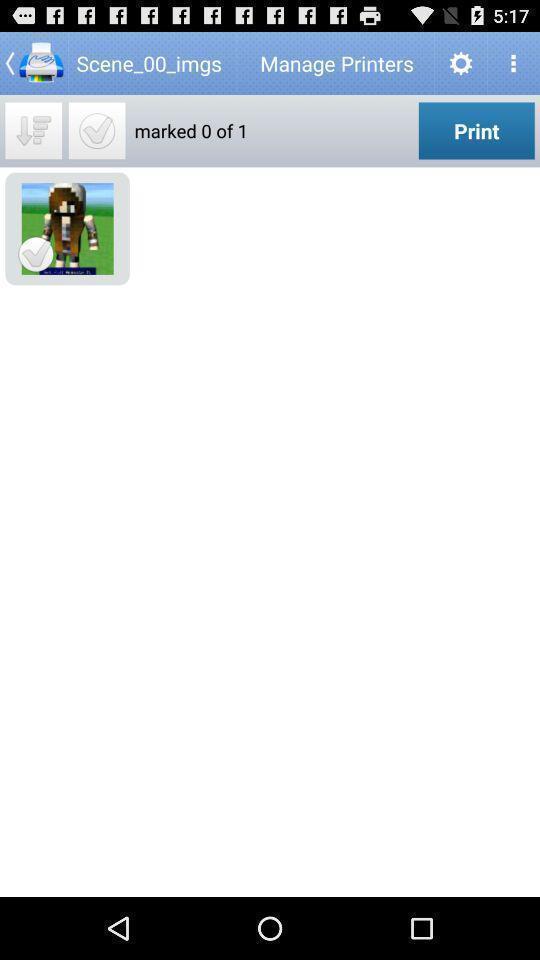Provide a textual representation of this image. Screen shows to manage printers. 